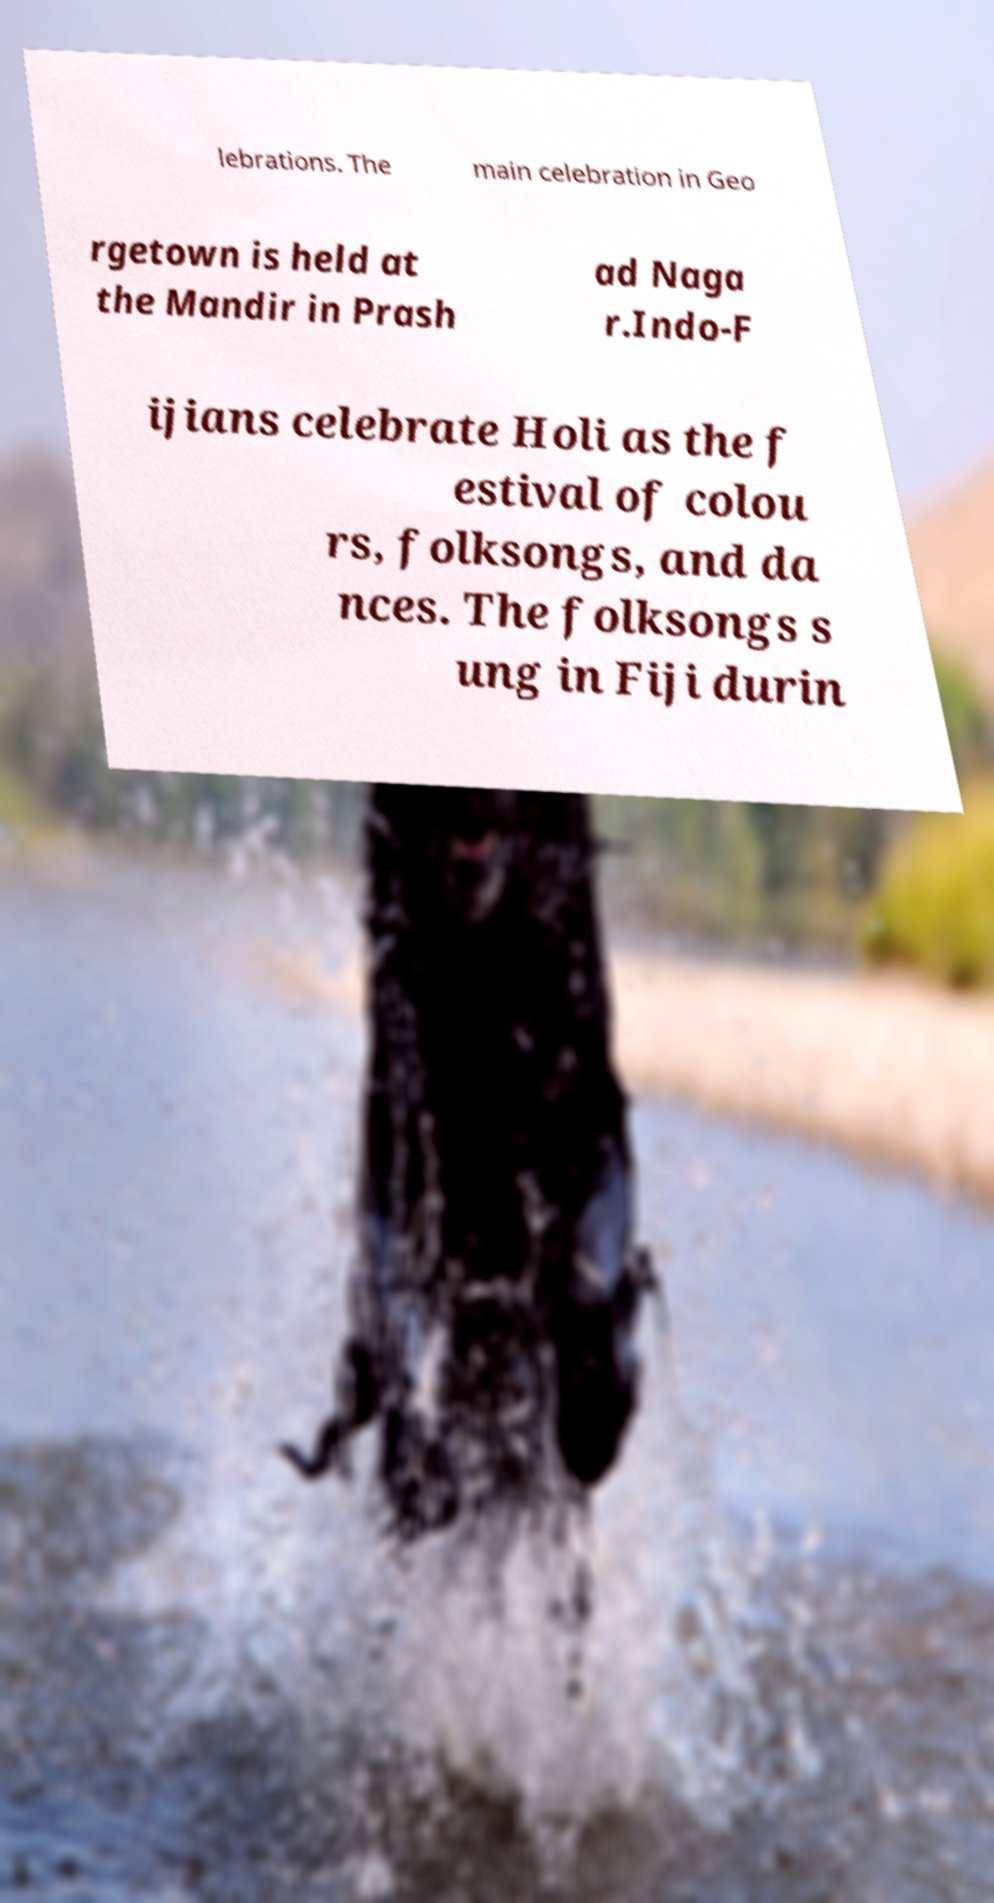What messages or text are displayed in this image? I need them in a readable, typed format. lebrations. The main celebration in Geo rgetown is held at the Mandir in Prash ad Naga r.Indo-F ijians celebrate Holi as the f estival of colou rs, folksongs, and da nces. The folksongs s ung in Fiji durin 